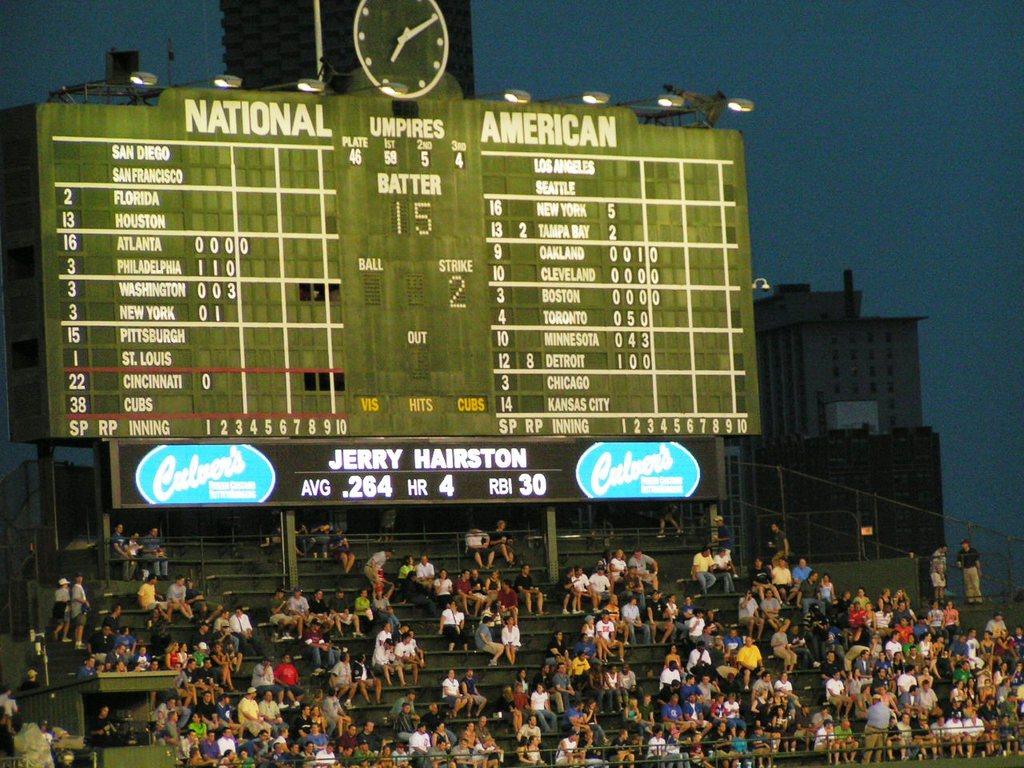What is the current batters name?
Provide a succinct answer. Jerry hairston. What time is it?
Give a very brief answer. 7:10. 